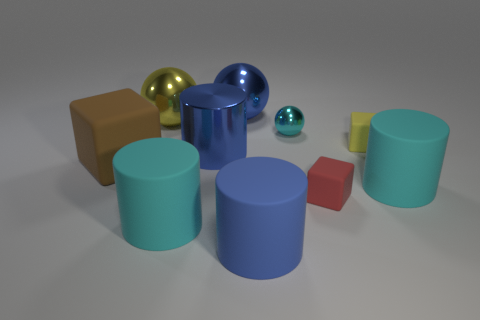Subtract all cubes. How many objects are left? 7 Add 1 blue matte cylinders. How many blue matte cylinders are left? 2 Add 5 tiny red rubber objects. How many tiny red rubber objects exist? 6 Subtract 1 blue cylinders. How many objects are left? 9 Subtract all large blue metal objects. Subtract all brown metal objects. How many objects are left? 8 